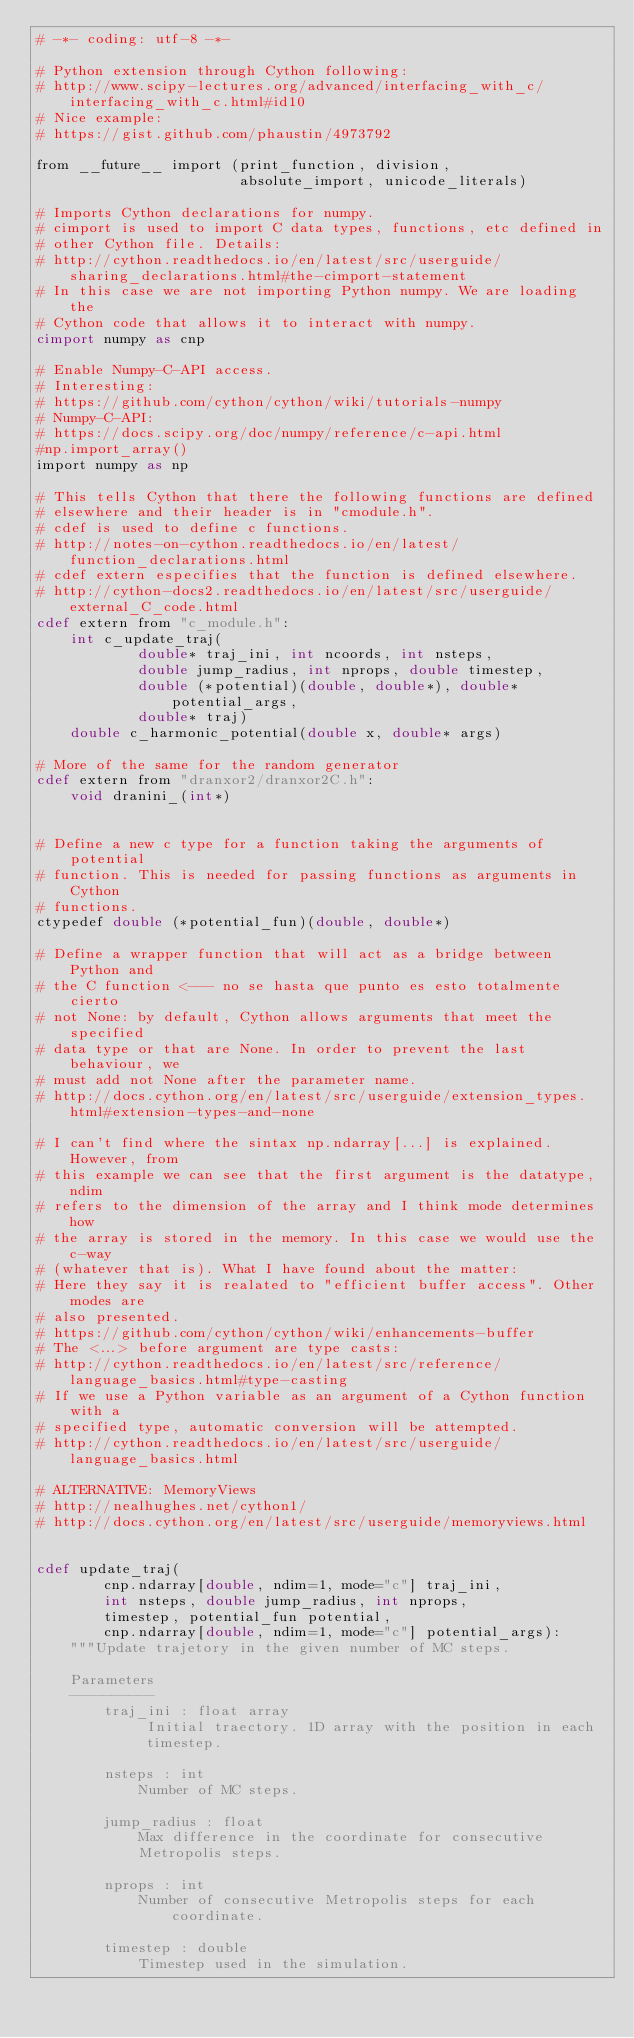Convert code to text. <code><loc_0><loc_0><loc_500><loc_500><_Cython_># -*- coding: utf-8 -*-

# Python extension through Cython following:
# http://www.scipy-lectures.org/advanced/interfacing_with_c/interfacing_with_c.html#id10
# Nice example:
# https://gist.github.com/phaustin/4973792

from __future__ import (print_function, division, 
                        absolute_import, unicode_literals)

# Imports Cython declarations for numpy.
# cimport is used to import C data types, functions, etc defined in 
# other Cython file. Details: 
# http://cython.readthedocs.io/en/latest/src/userguide/sharing_declarations.html#the-cimport-statement
# In this case we are not importing Python numpy. We are loading the 
# Cython code that allows it to interact with numpy.
cimport numpy as cnp

# Enable Numpy-C-API access.
# Interesting:
# https://github.com/cython/cython/wiki/tutorials-numpy
# Numpy-C-API:
# https://docs.scipy.org/doc/numpy/reference/c-api.html
#np.import_array()
import numpy as np

# This tells Cython that there the following functions are defined 
# elsewhere and their header is in "cmodule.h".
# cdef is used to define c functions.
# http://notes-on-cython.readthedocs.io/en/latest/function_declarations.html
# cdef extern especifies that the function is defined elsewhere.
# http://cython-docs2.readthedocs.io/en/latest/src/userguide/external_C_code.html
cdef extern from "c_module.h":
    int c_update_traj(
            double* traj_ini, int ncoords, int nsteps,
            double jump_radius, int nprops, double timestep,
            double (*potential)(double, double*), double* potential_args,
            double* traj)
    double c_harmonic_potential(double x, double* args)

# More of the same for the random generator
cdef extern from "dranxor2/dranxor2C.h":
    void dranini_(int*)


# Define a new c type for a function taking the arguments of potential
# function. This is needed for passing functions as arguments in Cython
# functions.
ctypedef double (*potential_fun)(double, double*)

# Define a wrapper function that will act as a bridge between Python and 
# the C function <--- no se hasta que punto es esto totalmente cierto
# not None: by default, Cython allows arguments that meet the specified
# data type or that are None. In order to prevent the last behaviour, we 
# must add not None after the parameter name.
# http://docs.cython.org/en/latest/src/userguide/extension_types.html#extension-types-and-none

# I can't find where the sintax np.ndarray[...] is explained. However, from 
# this example we can see that the first argument is the datatype, ndim 
# refers to the dimension of the array and I think mode determines how 
# the array is stored in the memory. In this case we would use the c-way
# (whatever that is). What I have found about the matter:
# Here they say it is realated to "efficient buffer access". Other modes are
# also presented.
# https://github.com/cython/cython/wiki/enhancements-buffer
# The <...> before argument are type casts:
# http://cython.readthedocs.io/en/latest/src/reference/language_basics.html#type-casting
# If we use a Python variable as an argument of a Cython function with a
# specified type, automatic conversion will be attempted.
# http://cython.readthedocs.io/en/latest/src/userguide/language_basics.html

# ALTERNATIVE: MemoryViews
# http://nealhughes.net/cython1/
# http://docs.cython.org/en/latest/src/userguide/memoryviews.html


cdef update_traj(
        cnp.ndarray[double, ndim=1, mode="c"] traj_ini,
        int nsteps, double jump_radius, int nprops, 
        timestep, potential_fun potential, 
        cnp.ndarray[double, ndim=1, mode="c"] potential_args):
    """Update trajetory in the given number of MC steps.
        
    Parameters
    ----------
        traj_ini : float array
             Initial traectory. 1D array with the position in each
             timestep.

        nsteps : int
            Number of MC steps.

        jump_radius : float
            Max difference in the coordinate for consecutive 
            Metropolis steps.

        nprops : int
            Number of consecutive Metropolis steps for each coordinate.

        timestep : double
            Timestep used in the simulation.
</code> 